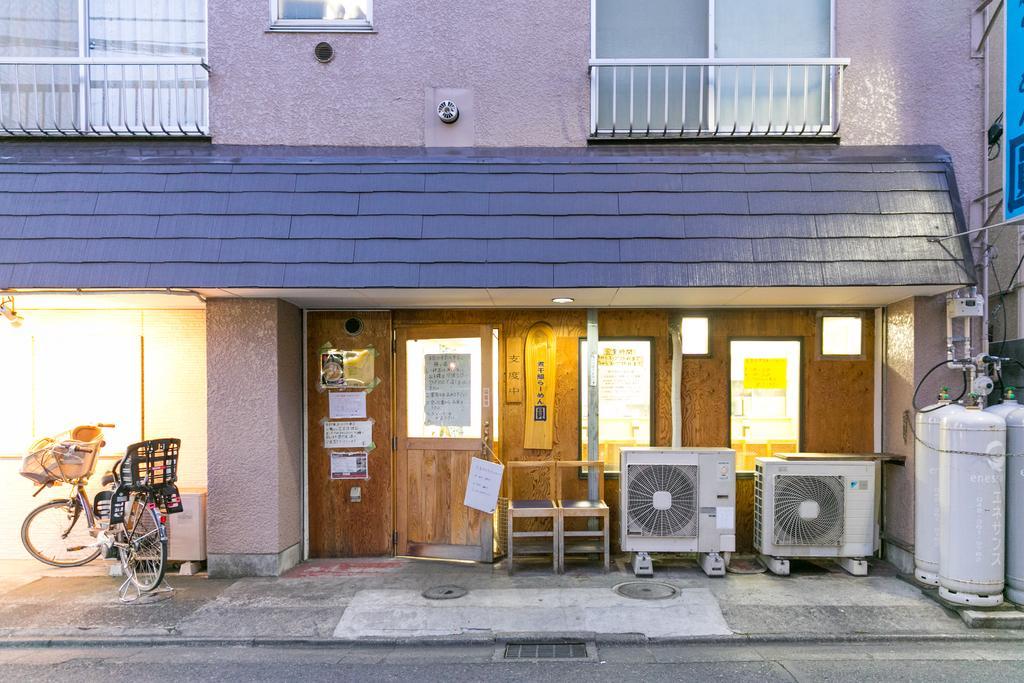How would you summarize this image in a sentence or two? In the image we can see there is a building and there is a bicycle which is parked beside the building and there are two chairs kept at the side near the door. 